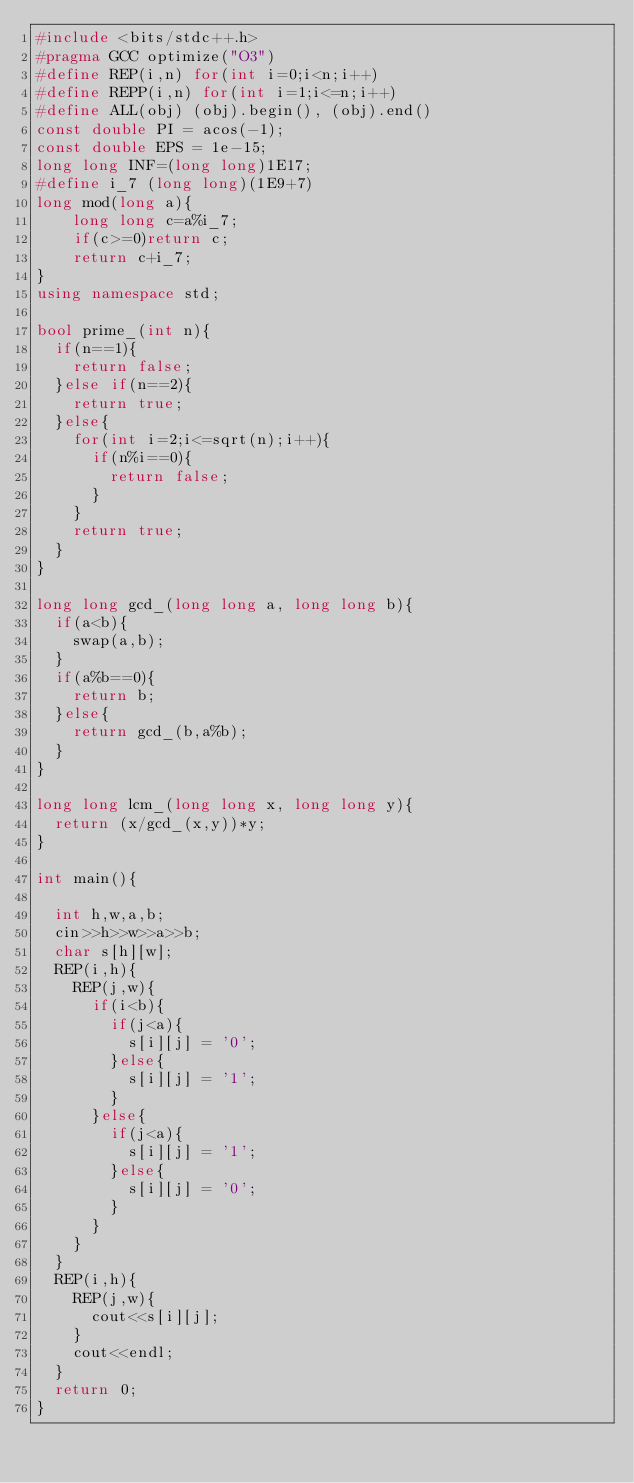<code> <loc_0><loc_0><loc_500><loc_500><_C++_>#include <bits/stdc++.h>
#pragma GCC optimize("O3")
#define REP(i,n) for(int i=0;i<n;i++)
#define REPP(i,n) for(int i=1;i<=n;i++)
#define ALL(obj) (obj).begin(), (obj).end()
const double PI = acos(-1);
const double EPS = 1e-15;
long long INF=(long long)1E17;
#define i_7 (long long)(1E9+7)
long mod(long a){
    long long c=a%i_7;
    if(c>=0)return c;
    return c+i_7;
}
using namespace std;

bool prime_(int n){
  if(n==1){
    return false;
  }else if(n==2){
    return true;
  }else{
    for(int i=2;i<=sqrt(n);i++){
      if(n%i==0){
        return false;
      }
    }
    return true;
  }
}

long long gcd_(long long a, long long b){
  if(a<b){
    swap(a,b);
  }
  if(a%b==0){
    return b;
  }else{
    return gcd_(b,a%b);
  }
}
 
long long lcm_(long long x, long long y){
  return (x/gcd_(x,y))*y;
}

int main(){
  
  int h,w,a,b;
  cin>>h>>w>>a>>b;
  char s[h][w];
  REP(i,h){
    REP(j,w){
      if(i<b){
        if(j<a){
          s[i][j] = '0';
        }else{
          s[i][j] = '1';
        }
      }else{
        if(j<a){
          s[i][j] = '1';
        }else{
          s[i][j] = '0';
        }
      }
    }
  }
  REP(i,h){
    REP(j,w){
      cout<<s[i][j];
    }
    cout<<endl;
  }
  return 0;
}</code> 